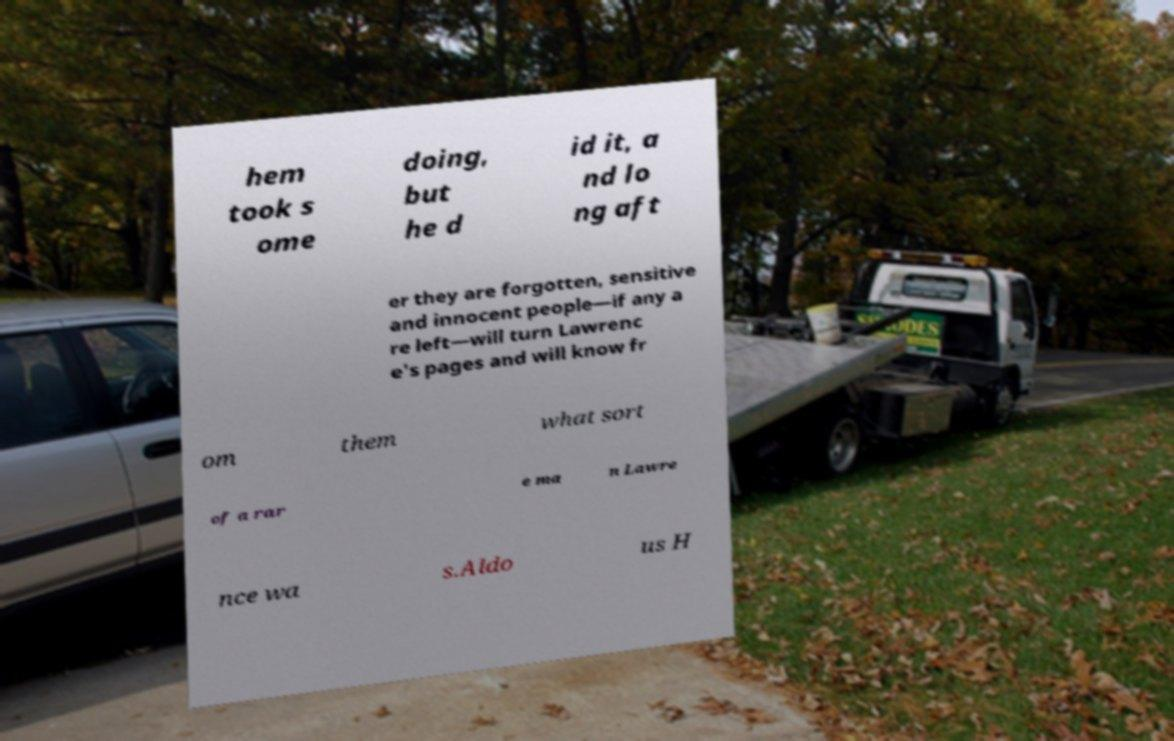What messages or text are displayed in this image? I need them in a readable, typed format. hem took s ome doing, but he d id it, a nd lo ng aft er they are forgotten, sensitive and innocent people—if any a re left—will turn Lawrenc e's pages and will know fr om them what sort of a rar e ma n Lawre nce wa s.Aldo us H 